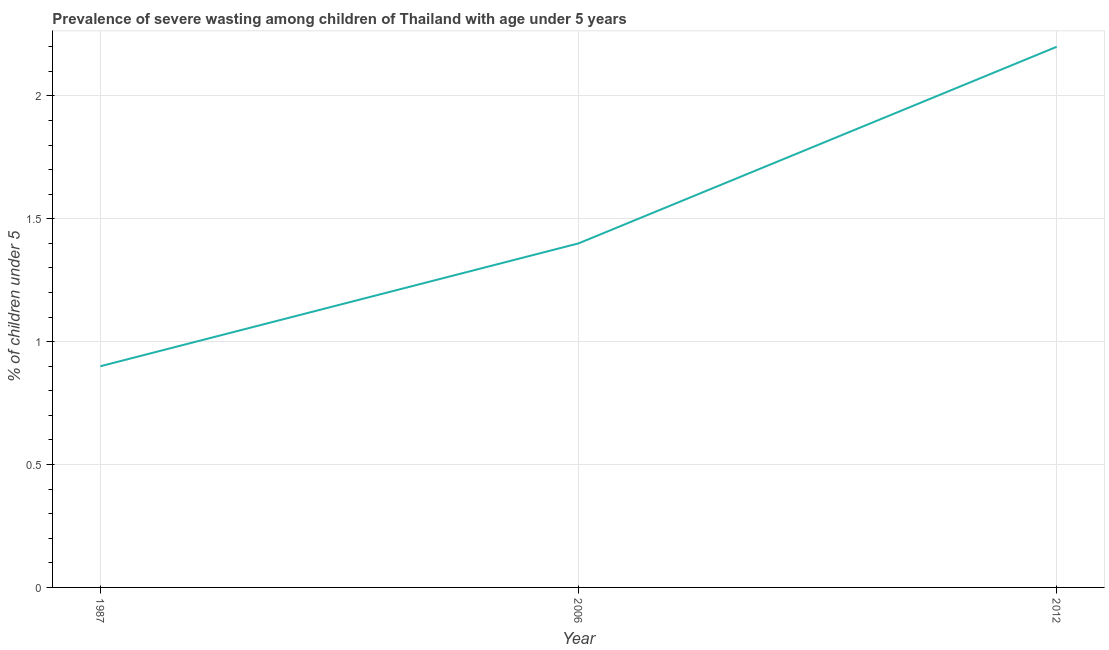What is the prevalence of severe wasting in 1987?
Your answer should be very brief. 0.9. Across all years, what is the maximum prevalence of severe wasting?
Provide a short and direct response. 2.2. Across all years, what is the minimum prevalence of severe wasting?
Give a very brief answer. 0.9. In which year was the prevalence of severe wasting maximum?
Offer a terse response. 2012. In which year was the prevalence of severe wasting minimum?
Keep it short and to the point. 1987. What is the sum of the prevalence of severe wasting?
Provide a short and direct response. 4.5. What is the difference between the prevalence of severe wasting in 1987 and 2012?
Ensure brevity in your answer.  -1.3. What is the average prevalence of severe wasting per year?
Your response must be concise. 1.5. What is the median prevalence of severe wasting?
Provide a short and direct response. 1.4. What is the ratio of the prevalence of severe wasting in 2006 to that in 2012?
Keep it short and to the point. 0.64. Is the prevalence of severe wasting in 1987 less than that in 2012?
Keep it short and to the point. Yes. What is the difference between the highest and the second highest prevalence of severe wasting?
Your answer should be very brief. 0.8. Is the sum of the prevalence of severe wasting in 1987 and 2006 greater than the maximum prevalence of severe wasting across all years?
Offer a terse response. Yes. What is the difference between the highest and the lowest prevalence of severe wasting?
Keep it short and to the point. 1.3. In how many years, is the prevalence of severe wasting greater than the average prevalence of severe wasting taken over all years?
Offer a terse response. 1. Does the prevalence of severe wasting monotonically increase over the years?
Ensure brevity in your answer.  Yes. Does the graph contain any zero values?
Provide a succinct answer. No. What is the title of the graph?
Offer a very short reply. Prevalence of severe wasting among children of Thailand with age under 5 years. What is the label or title of the X-axis?
Give a very brief answer. Year. What is the label or title of the Y-axis?
Your answer should be very brief.  % of children under 5. What is the  % of children under 5 of 1987?
Your answer should be compact. 0.9. What is the  % of children under 5 of 2006?
Provide a succinct answer. 1.4. What is the  % of children under 5 of 2012?
Give a very brief answer. 2.2. What is the difference between the  % of children under 5 in 1987 and 2012?
Make the answer very short. -1.3. What is the ratio of the  % of children under 5 in 1987 to that in 2006?
Your response must be concise. 0.64. What is the ratio of the  % of children under 5 in 1987 to that in 2012?
Provide a short and direct response. 0.41. What is the ratio of the  % of children under 5 in 2006 to that in 2012?
Provide a short and direct response. 0.64. 